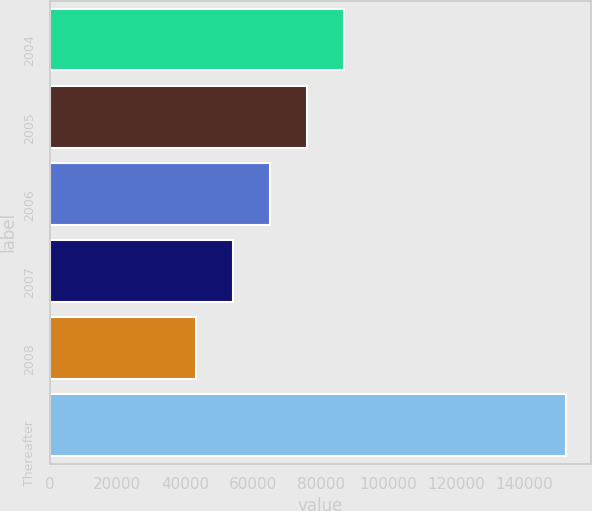Convert chart to OTSL. <chart><loc_0><loc_0><loc_500><loc_500><bar_chart><fcel>2004<fcel>2005<fcel>2006<fcel>2007<fcel>2008<fcel>Thereafter<nl><fcel>86828<fcel>75916<fcel>65004<fcel>54092<fcel>43180<fcel>152300<nl></chart> 